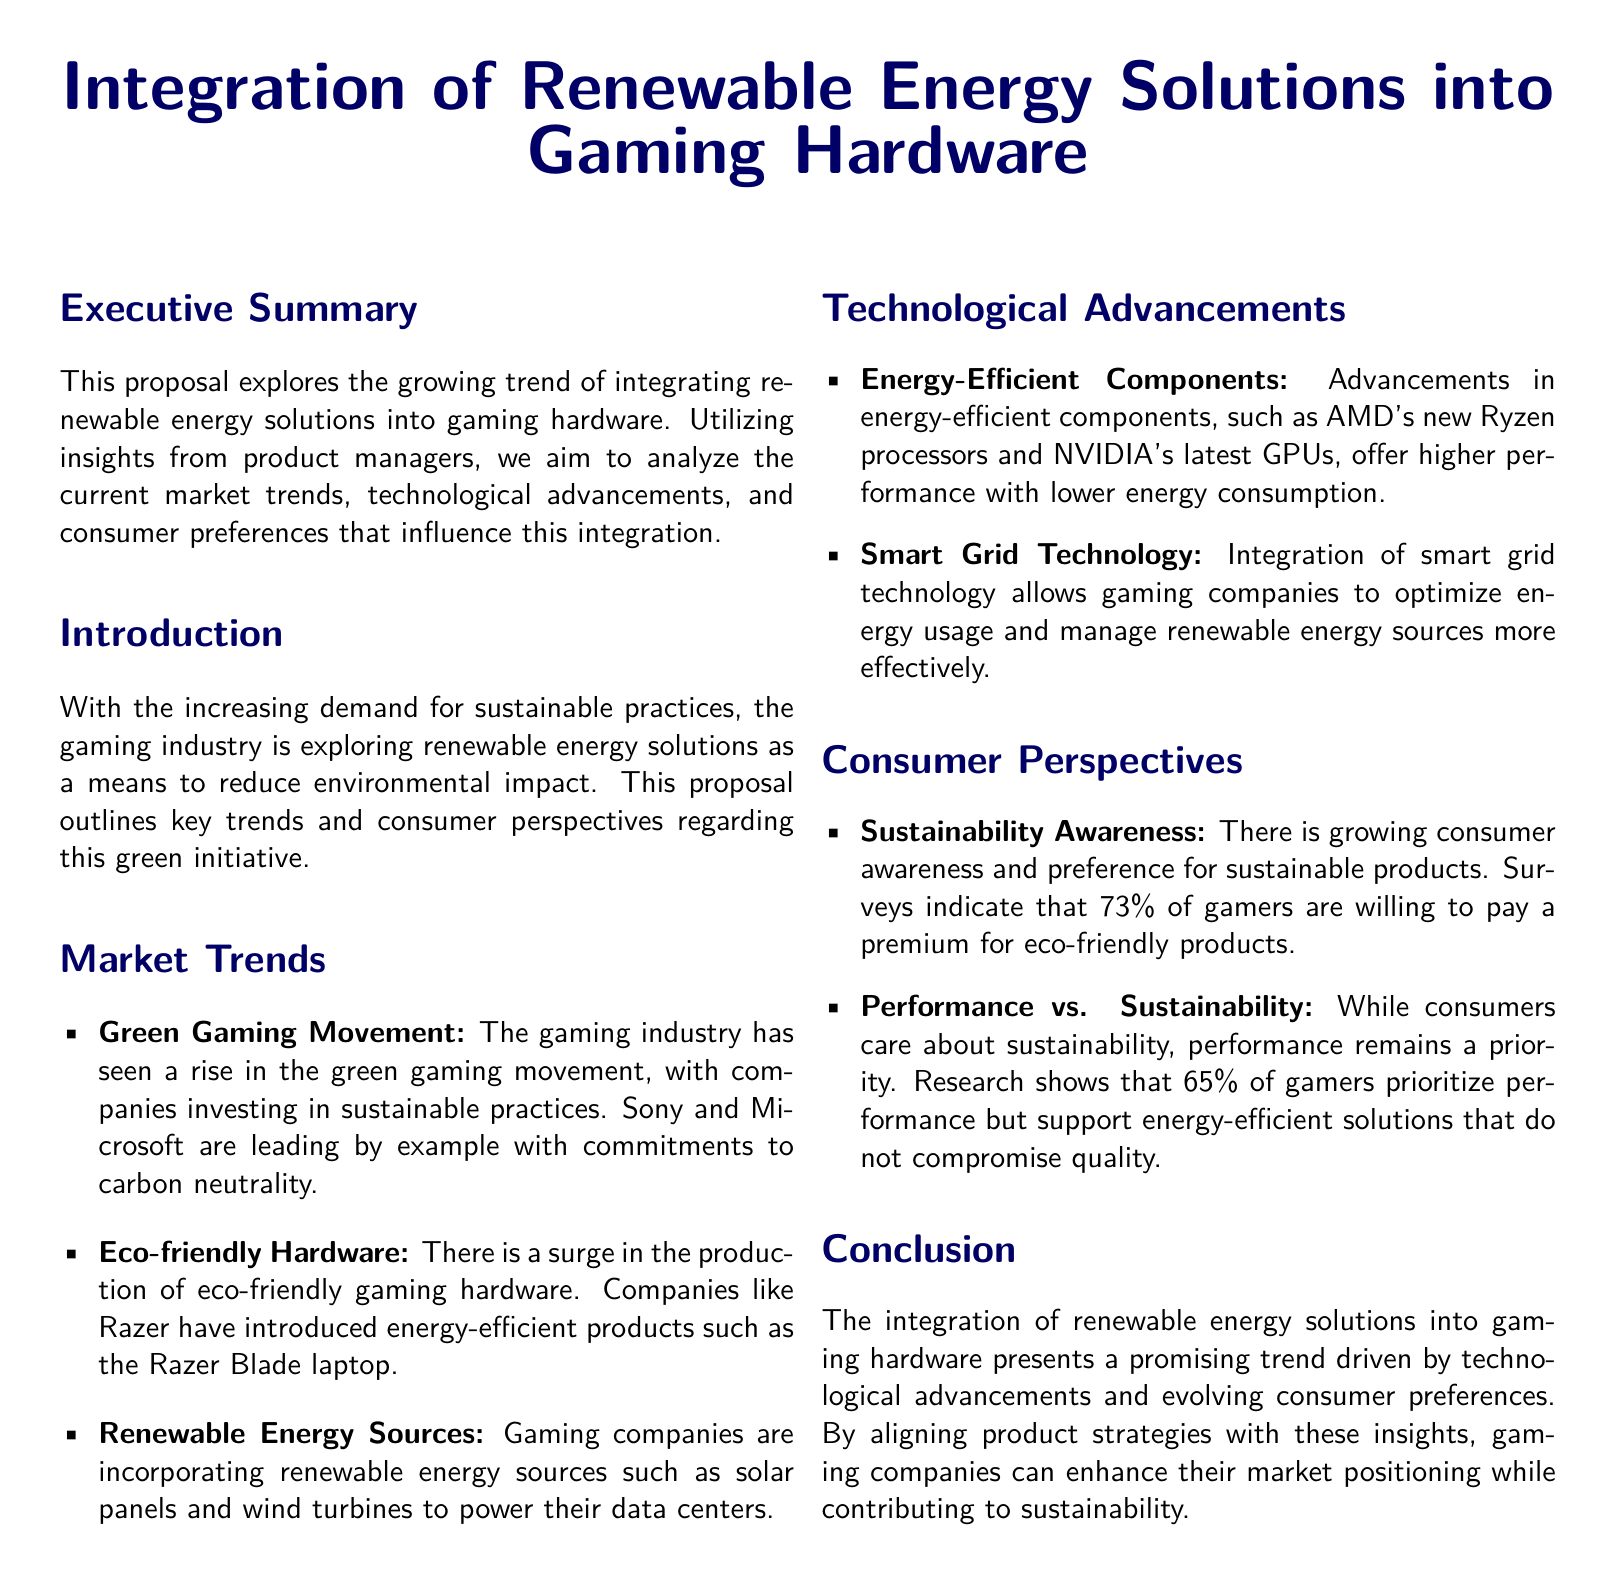What is the main focus of the proposal? The main focus is to explore the integration of renewable energy solutions into gaming hardware.
Answer: Integration of renewable energy solutions into gaming hardware Which companies are mentioned as leading in the green gaming movement? Sony and Microsoft are specifically mentioned in the document as leaders in the green gaming movement.
Answer: Sony and Microsoft What percentage of gamers are willing to pay a premium for eco-friendly products? The document states that 73% of gamers are willing to pay a premium for these products.
Answer: 73% What type of technology allows companies to optimize energy usage? The document mentions smart grid technology for optimizing energy usage.
Answer: Smart grid technology Which product is cited as an example of eco-friendly hardware? The Razer Blade laptop is cited as an example of eco-friendly hardware in the document.
Answer: Razer Blade laptop 